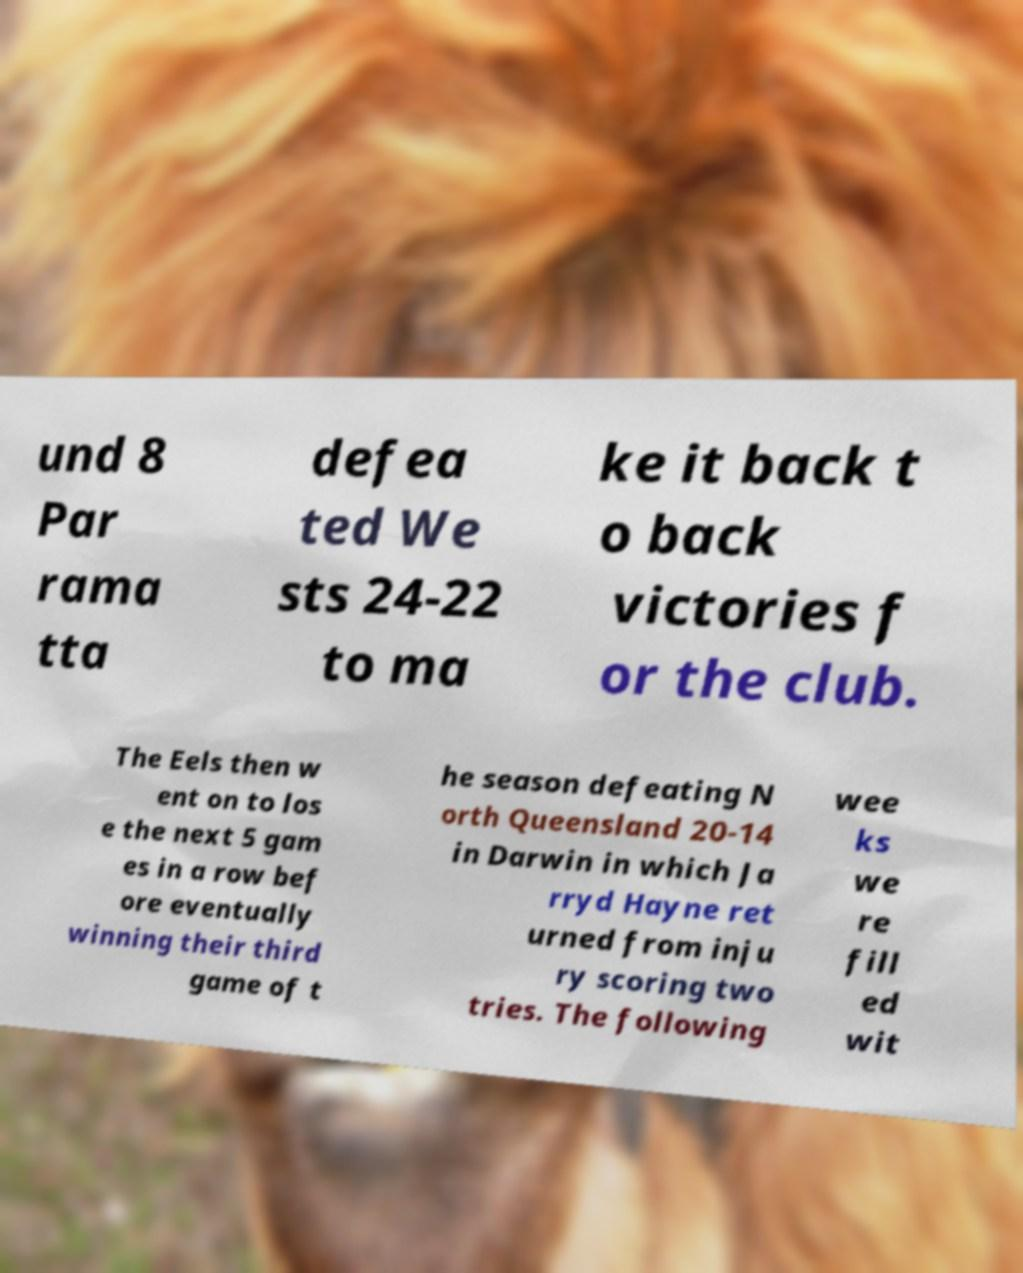Could you extract and type out the text from this image? und 8 Par rama tta defea ted We sts 24-22 to ma ke it back t o back victories f or the club. The Eels then w ent on to los e the next 5 gam es in a row bef ore eventually winning their third game of t he season defeating N orth Queensland 20-14 in Darwin in which Ja rryd Hayne ret urned from inju ry scoring two tries. The following wee ks we re fill ed wit 